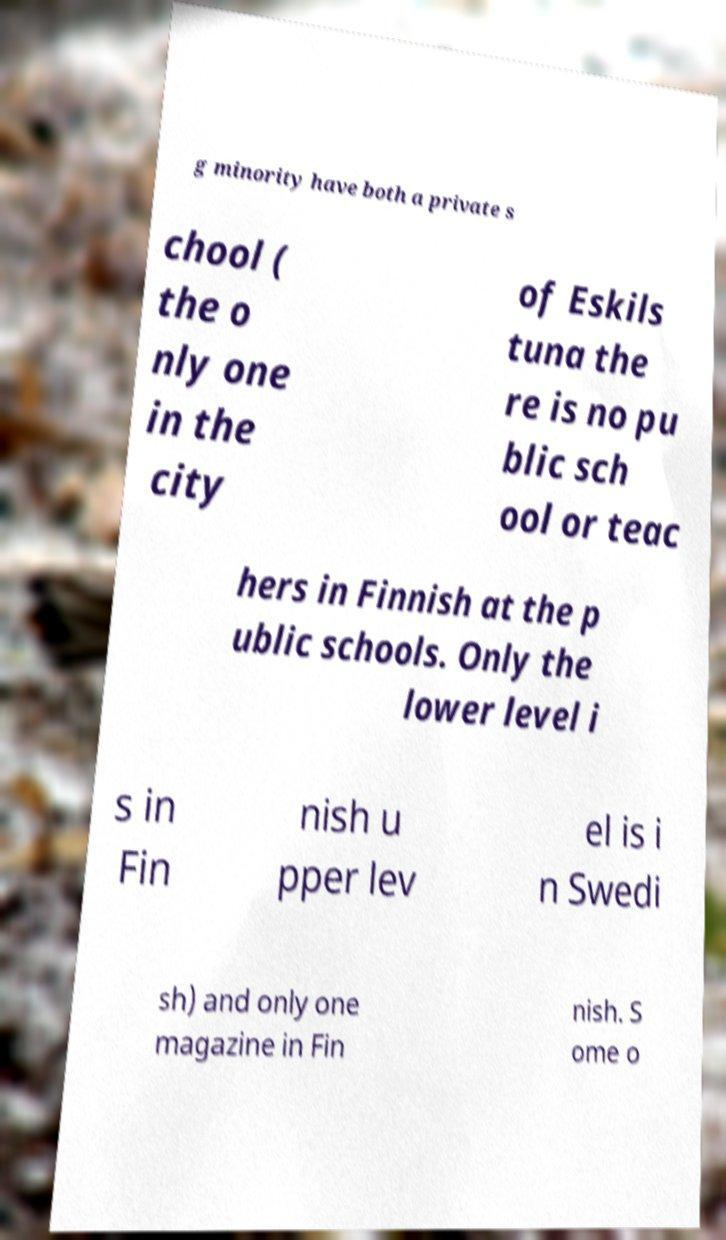Please identify and transcribe the text found in this image. g minority have both a private s chool ( the o nly one in the city of Eskils tuna the re is no pu blic sch ool or teac hers in Finnish at the p ublic schools. Only the lower level i s in Fin nish u pper lev el is i n Swedi sh) and only one magazine in Fin nish. S ome o 